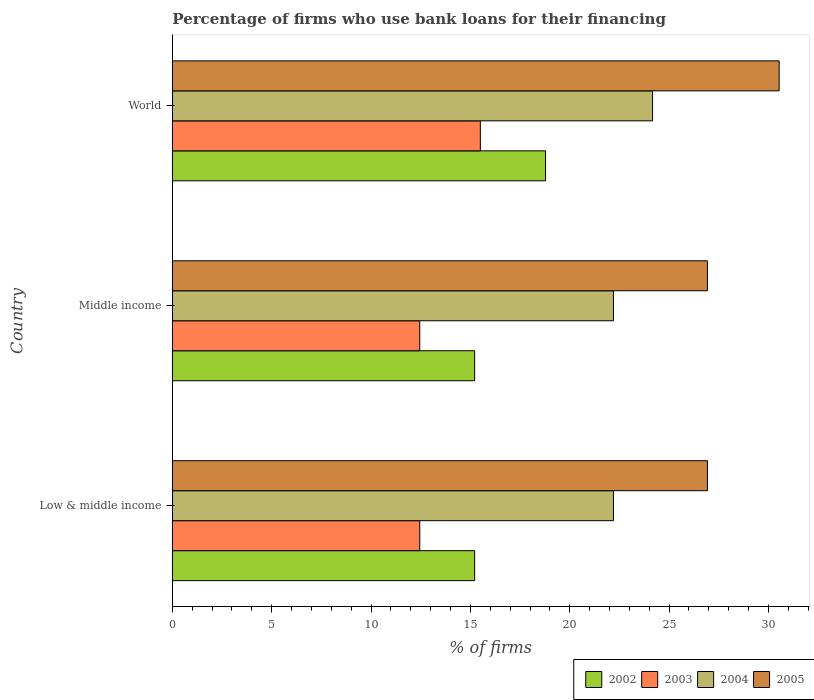How many groups of bars are there?
Keep it short and to the point. 3. Are the number of bars per tick equal to the number of legend labels?
Ensure brevity in your answer.  Yes. How many bars are there on the 3rd tick from the top?
Keep it short and to the point. 4. In how many cases, is the number of bars for a given country not equal to the number of legend labels?
Give a very brief answer. 0. What is the percentage of firms who use bank loans for their financing in 2004 in Middle income?
Make the answer very short. 22.2. Across all countries, what is the maximum percentage of firms who use bank loans for their financing in 2004?
Make the answer very short. 24.17. Across all countries, what is the minimum percentage of firms who use bank loans for their financing in 2004?
Give a very brief answer. 22.2. What is the total percentage of firms who use bank loans for their financing in 2002 in the graph?
Offer a very short reply. 49.21. What is the difference between the percentage of firms who use bank loans for their financing in 2003 in Low & middle income and that in World?
Keep it short and to the point. -3.05. What is the difference between the percentage of firms who use bank loans for their financing in 2005 in Middle income and the percentage of firms who use bank loans for their financing in 2003 in World?
Keep it short and to the point. 11.43. What is the average percentage of firms who use bank loans for their financing in 2003 per country?
Your answer should be compact. 13.47. What is the difference between the percentage of firms who use bank loans for their financing in 2004 and percentage of firms who use bank loans for their financing in 2002 in Middle income?
Keep it short and to the point. 6.99. What is the ratio of the percentage of firms who use bank loans for their financing in 2004 in Low & middle income to that in World?
Provide a short and direct response. 0.92. What is the difference between the highest and the second highest percentage of firms who use bank loans for their financing in 2002?
Make the answer very short. 3.57. What is the difference between the highest and the lowest percentage of firms who use bank loans for their financing in 2005?
Your answer should be compact. 3.61. In how many countries, is the percentage of firms who use bank loans for their financing in 2004 greater than the average percentage of firms who use bank loans for their financing in 2004 taken over all countries?
Offer a very short reply. 1. Is the sum of the percentage of firms who use bank loans for their financing in 2004 in Low & middle income and World greater than the maximum percentage of firms who use bank loans for their financing in 2003 across all countries?
Offer a very short reply. Yes. Is it the case that in every country, the sum of the percentage of firms who use bank loans for their financing in 2003 and percentage of firms who use bank loans for their financing in 2002 is greater than the sum of percentage of firms who use bank loans for their financing in 2005 and percentage of firms who use bank loans for their financing in 2004?
Your response must be concise. No. What does the 3rd bar from the top in Low & middle income represents?
Ensure brevity in your answer.  2003. Is it the case that in every country, the sum of the percentage of firms who use bank loans for their financing in 2003 and percentage of firms who use bank loans for their financing in 2002 is greater than the percentage of firms who use bank loans for their financing in 2004?
Give a very brief answer. Yes. How many bars are there?
Ensure brevity in your answer.  12. Are all the bars in the graph horizontal?
Provide a short and direct response. Yes. How many countries are there in the graph?
Provide a succinct answer. 3. What is the difference between two consecutive major ticks on the X-axis?
Provide a succinct answer. 5. Are the values on the major ticks of X-axis written in scientific E-notation?
Provide a short and direct response. No. How many legend labels are there?
Your response must be concise. 4. How are the legend labels stacked?
Provide a short and direct response. Horizontal. What is the title of the graph?
Keep it short and to the point. Percentage of firms who use bank loans for their financing. What is the label or title of the X-axis?
Keep it short and to the point. % of firms. What is the % of firms in 2002 in Low & middle income?
Offer a terse response. 15.21. What is the % of firms in 2003 in Low & middle income?
Ensure brevity in your answer.  12.45. What is the % of firms of 2004 in Low & middle income?
Provide a succinct answer. 22.2. What is the % of firms of 2005 in Low & middle income?
Provide a succinct answer. 26.93. What is the % of firms in 2002 in Middle income?
Your answer should be compact. 15.21. What is the % of firms of 2003 in Middle income?
Make the answer very short. 12.45. What is the % of firms in 2004 in Middle income?
Offer a terse response. 22.2. What is the % of firms in 2005 in Middle income?
Offer a terse response. 26.93. What is the % of firms of 2002 in World?
Your answer should be very brief. 18.78. What is the % of firms in 2004 in World?
Ensure brevity in your answer.  24.17. What is the % of firms of 2005 in World?
Offer a very short reply. 30.54. Across all countries, what is the maximum % of firms of 2002?
Offer a very short reply. 18.78. Across all countries, what is the maximum % of firms in 2003?
Provide a succinct answer. 15.5. Across all countries, what is the maximum % of firms of 2004?
Provide a short and direct response. 24.17. Across all countries, what is the maximum % of firms of 2005?
Your answer should be compact. 30.54. Across all countries, what is the minimum % of firms in 2002?
Your response must be concise. 15.21. Across all countries, what is the minimum % of firms in 2003?
Your answer should be very brief. 12.45. Across all countries, what is the minimum % of firms of 2004?
Your answer should be very brief. 22.2. Across all countries, what is the minimum % of firms in 2005?
Your answer should be very brief. 26.93. What is the total % of firms of 2002 in the graph?
Your answer should be very brief. 49.21. What is the total % of firms in 2003 in the graph?
Provide a short and direct response. 40.4. What is the total % of firms of 2004 in the graph?
Offer a terse response. 68.57. What is the total % of firms of 2005 in the graph?
Ensure brevity in your answer.  84.39. What is the difference between the % of firms of 2002 in Low & middle income and that in Middle income?
Give a very brief answer. 0. What is the difference between the % of firms of 2004 in Low & middle income and that in Middle income?
Make the answer very short. 0. What is the difference between the % of firms in 2002 in Low & middle income and that in World?
Offer a very short reply. -3.57. What is the difference between the % of firms of 2003 in Low & middle income and that in World?
Offer a terse response. -3.05. What is the difference between the % of firms in 2004 in Low & middle income and that in World?
Your response must be concise. -1.97. What is the difference between the % of firms in 2005 in Low & middle income and that in World?
Your answer should be compact. -3.61. What is the difference between the % of firms in 2002 in Middle income and that in World?
Provide a succinct answer. -3.57. What is the difference between the % of firms in 2003 in Middle income and that in World?
Provide a short and direct response. -3.05. What is the difference between the % of firms in 2004 in Middle income and that in World?
Keep it short and to the point. -1.97. What is the difference between the % of firms in 2005 in Middle income and that in World?
Your answer should be compact. -3.61. What is the difference between the % of firms of 2002 in Low & middle income and the % of firms of 2003 in Middle income?
Ensure brevity in your answer.  2.76. What is the difference between the % of firms of 2002 in Low & middle income and the % of firms of 2004 in Middle income?
Provide a short and direct response. -6.99. What is the difference between the % of firms in 2002 in Low & middle income and the % of firms in 2005 in Middle income?
Offer a very short reply. -11.72. What is the difference between the % of firms of 2003 in Low & middle income and the % of firms of 2004 in Middle income?
Provide a succinct answer. -9.75. What is the difference between the % of firms in 2003 in Low & middle income and the % of firms in 2005 in Middle income?
Make the answer very short. -14.48. What is the difference between the % of firms in 2004 in Low & middle income and the % of firms in 2005 in Middle income?
Make the answer very short. -4.73. What is the difference between the % of firms of 2002 in Low & middle income and the % of firms of 2003 in World?
Keep it short and to the point. -0.29. What is the difference between the % of firms in 2002 in Low & middle income and the % of firms in 2004 in World?
Your answer should be very brief. -8.95. What is the difference between the % of firms in 2002 in Low & middle income and the % of firms in 2005 in World?
Provide a succinct answer. -15.33. What is the difference between the % of firms of 2003 in Low & middle income and the % of firms of 2004 in World?
Provide a succinct answer. -11.72. What is the difference between the % of firms of 2003 in Low & middle income and the % of firms of 2005 in World?
Ensure brevity in your answer.  -18.09. What is the difference between the % of firms of 2004 in Low & middle income and the % of firms of 2005 in World?
Give a very brief answer. -8.34. What is the difference between the % of firms in 2002 in Middle income and the % of firms in 2003 in World?
Provide a short and direct response. -0.29. What is the difference between the % of firms of 2002 in Middle income and the % of firms of 2004 in World?
Offer a terse response. -8.95. What is the difference between the % of firms of 2002 in Middle income and the % of firms of 2005 in World?
Ensure brevity in your answer.  -15.33. What is the difference between the % of firms of 2003 in Middle income and the % of firms of 2004 in World?
Make the answer very short. -11.72. What is the difference between the % of firms in 2003 in Middle income and the % of firms in 2005 in World?
Offer a terse response. -18.09. What is the difference between the % of firms in 2004 in Middle income and the % of firms in 2005 in World?
Your response must be concise. -8.34. What is the average % of firms in 2002 per country?
Offer a terse response. 16.4. What is the average % of firms in 2003 per country?
Your answer should be very brief. 13.47. What is the average % of firms in 2004 per country?
Offer a very short reply. 22.86. What is the average % of firms in 2005 per country?
Your response must be concise. 28.13. What is the difference between the % of firms of 2002 and % of firms of 2003 in Low & middle income?
Give a very brief answer. 2.76. What is the difference between the % of firms in 2002 and % of firms in 2004 in Low & middle income?
Offer a very short reply. -6.99. What is the difference between the % of firms in 2002 and % of firms in 2005 in Low & middle income?
Offer a very short reply. -11.72. What is the difference between the % of firms of 2003 and % of firms of 2004 in Low & middle income?
Give a very brief answer. -9.75. What is the difference between the % of firms in 2003 and % of firms in 2005 in Low & middle income?
Your answer should be very brief. -14.48. What is the difference between the % of firms of 2004 and % of firms of 2005 in Low & middle income?
Your response must be concise. -4.73. What is the difference between the % of firms of 2002 and % of firms of 2003 in Middle income?
Offer a terse response. 2.76. What is the difference between the % of firms in 2002 and % of firms in 2004 in Middle income?
Provide a short and direct response. -6.99. What is the difference between the % of firms in 2002 and % of firms in 2005 in Middle income?
Give a very brief answer. -11.72. What is the difference between the % of firms in 2003 and % of firms in 2004 in Middle income?
Provide a succinct answer. -9.75. What is the difference between the % of firms in 2003 and % of firms in 2005 in Middle income?
Provide a succinct answer. -14.48. What is the difference between the % of firms in 2004 and % of firms in 2005 in Middle income?
Offer a very short reply. -4.73. What is the difference between the % of firms of 2002 and % of firms of 2003 in World?
Provide a short and direct response. 3.28. What is the difference between the % of firms in 2002 and % of firms in 2004 in World?
Offer a very short reply. -5.39. What is the difference between the % of firms of 2002 and % of firms of 2005 in World?
Offer a very short reply. -11.76. What is the difference between the % of firms of 2003 and % of firms of 2004 in World?
Keep it short and to the point. -8.67. What is the difference between the % of firms of 2003 and % of firms of 2005 in World?
Keep it short and to the point. -15.04. What is the difference between the % of firms in 2004 and % of firms in 2005 in World?
Offer a terse response. -6.37. What is the ratio of the % of firms of 2002 in Low & middle income to that in Middle income?
Offer a very short reply. 1. What is the ratio of the % of firms in 2003 in Low & middle income to that in Middle income?
Ensure brevity in your answer.  1. What is the ratio of the % of firms in 2005 in Low & middle income to that in Middle income?
Your answer should be compact. 1. What is the ratio of the % of firms of 2002 in Low & middle income to that in World?
Keep it short and to the point. 0.81. What is the ratio of the % of firms in 2003 in Low & middle income to that in World?
Offer a very short reply. 0.8. What is the ratio of the % of firms in 2004 in Low & middle income to that in World?
Offer a terse response. 0.92. What is the ratio of the % of firms in 2005 in Low & middle income to that in World?
Offer a very short reply. 0.88. What is the ratio of the % of firms of 2002 in Middle income to that in World?
Your answer should be compact. 0.81. What is the ratio of the % of firms of 2003 in Middle income to that in World?
Your response must be concise. 0.8. What is the ratio of the % of firms of 2004 in Middle income to that in World?
Give a very brief answer. 0.92. What is the ratio of the % of firms of 2005 in Middle income to that in World?
Your response must be concise. 0.88. What is the difference between the highest and the second highest % of firms of 2002?
Make the answer very short. 3.57. What is the difference between the highest and the second highest % of firms in 2003?
Make the answer very short. 3.05. What is the difference between the highest and the second highest % of firms of 2004?
Ensure brevity in your answer.  1.97. What is the difference between the highest and the second highest % of firms in 2005?
Offer a terse response. 3.61. What is the difference between the highest and the lowest % of firms in 2002?
Make the answer very short. 3.57. What is the difference between the highest and the lowest % of firms in 2003?
Your answer should be very brief. 3.05. What is the difference between the highest and the lowest % of firms of 2004?
Provide a short and direct response. 1.97. What is the difference between the highest and the lowest % of firms in 2005?
Offer a terse response. 3.61. 